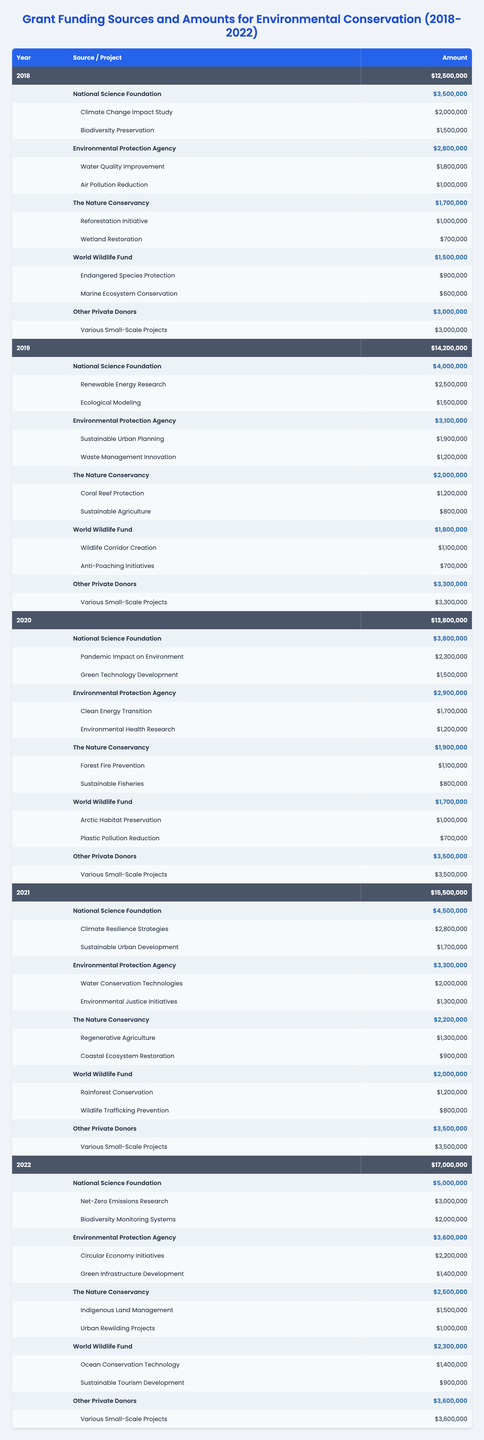What was the total funding received in 2020? The total funding for the year 2020 is listed in the table, and it states that the funding amount is $13,800,000.
Answer: $13,800,000 Which source provided the highest funding in 2021? To find the highest funding source for 2021, we refer to the funding amounts for each source under that year. The National Science Foundation provided $4,500,000, which is higher than all other sources.
Answer: National Science Foundation What is the total amount of funding from Other Private Donors from 2018 to 2022? We need to sum the amounts from Other Private Donors for each year: 2018 ($3,000,000) + 2019 ($3,300,000) + 2020 ($3,500,000) + 2021 ($3,500,000) + 2022 ($3,600,000) = $16,900,000.
Answer: $16,900,000 In which year did The Nature Conservancy provide the least funding? We compare the funding amounts from The Nature Conservancy for each year: 2018 ($1,700,000), 2019 ($2,000,000), 2020 ($1,900,000), 2021 ($2,200,000), and 2022 ($2,500,000). The least funding was provided in 2018.
Answer: 2018 Was the total funding in 2022 higher than the average funding for the years 2018 to 2021? First, calculate the average funding for 2018 to 2021: (12,500,000 + 14,200,000 + 13,800,000 + 15,500,000) / 4 = $14,000,000. Then compare it to 2022 funding, which is $17,000,000. Yes, 2022 funding is higher than $14,000,000.
Answer: Yes What is the percentage increase in total funding from 2018 to 2022? The total funding in 2018 is $12,500,000 and in 2022 is $17,000,000. The increase is $17,000,000 - $12,500,000 = $4,500,000. To find the percentage increase: ($4,500,000 / $12,500,000) * 100 = 36%.
Answer: 36% Which year had the highest total amount from the World Wildlife Fund, and what was the amount? Looking at the amounts provided by the World Wildlife Fund: 2018 ($1,500,000), 2019 ($1,800,000), 2020 ($1,700,000), 2021 ($2,000,000), and 2022 ($2,300,000). The highest amount was in 2022 with $2,300,000.
Answer: 2022, $2,300,000 How much funding was allocated to the project "Climate Change Impact Study" in 2018? The funding allocated to the project "Climate Change Impact Study" is found under the National Science Foundation in 2018, and it states $2,000,000.
Answer: $2,000,000 What is the total funding from the Environmental Protection Agency over the five years? We sum the funding amounts from the Environmental Protection Agency for each year: 2018 ($2,800,000) + 2019 ($3,100,000) + 2020 ($2,900,000) + 2021 ($3,300,000) + 2022 ($3,600,000) = $15,700,000.
Answer: $15,700,000 Does the funding from The Nature Conservancy ever exceed $2,500,000 between 2018 and 2022? Checking the annual funding from The Nature Conservancy: 2018 ($1,700,000), 2019 ($2,000,000), 2020 ($1,900,000), 2021 ($2,200,000), and 2022 ($2,500,000). None of the amounts exceed $2,500,000.
Answer: No 